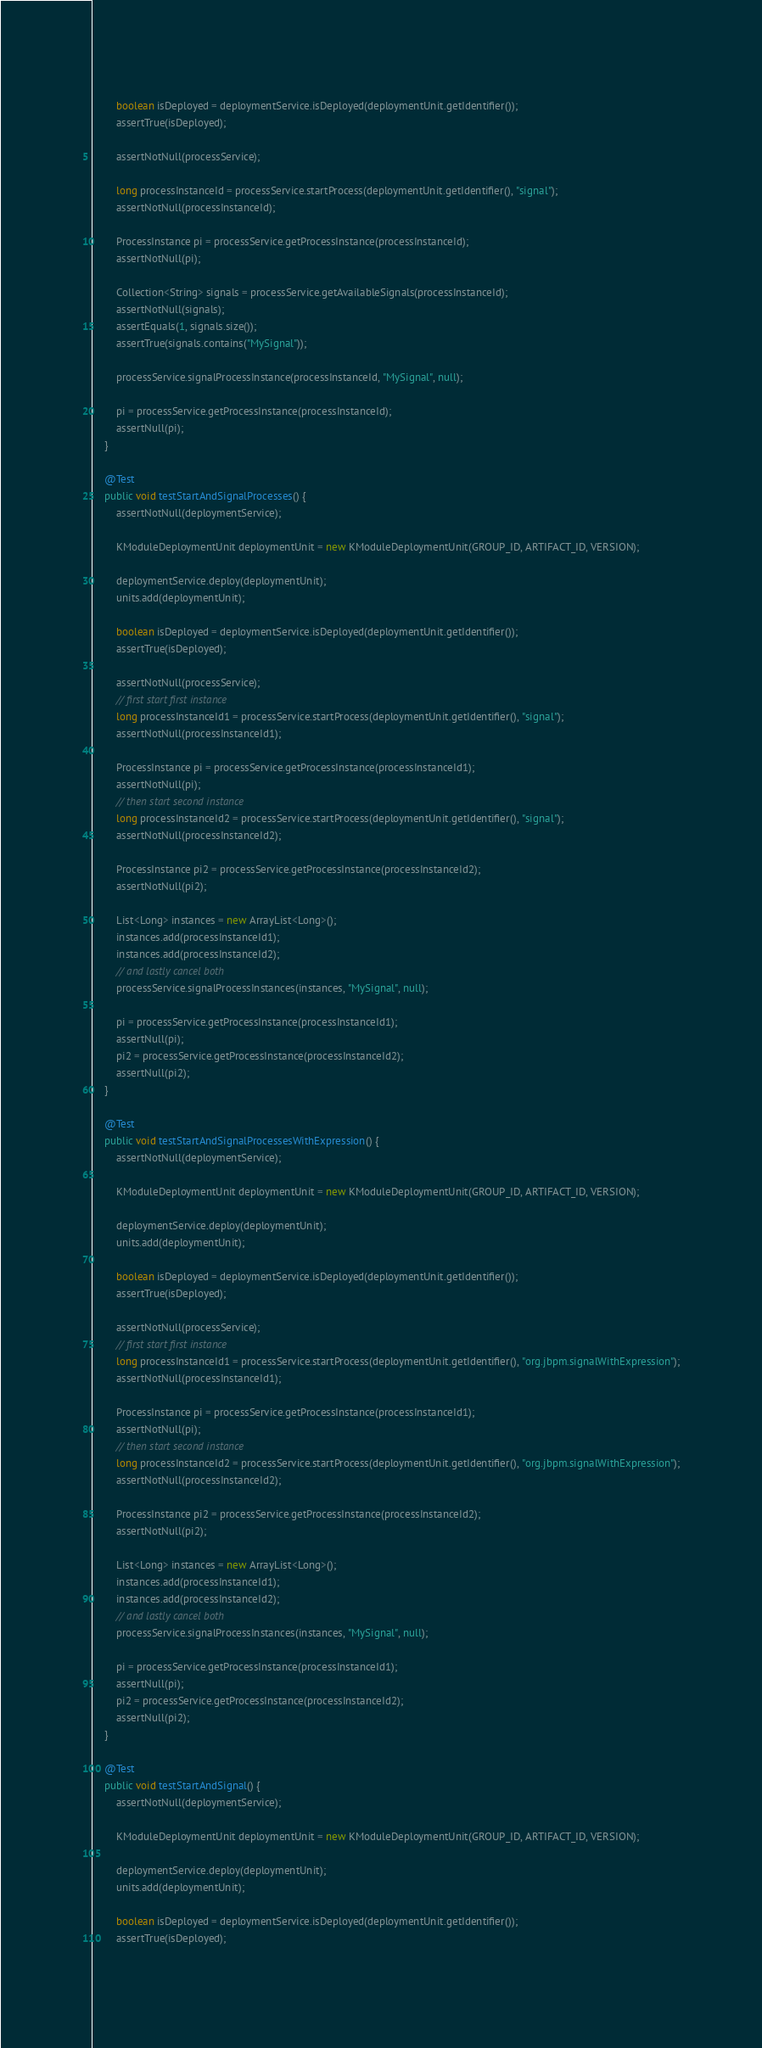<code> <loc_0><loc_0><loc_500><loc_500><_Java_>        
        boolean isDeployed = deploymentService.isDeployed(deploymentUnit.getIdentifier());
    	assertTrue(isDeployed);
    	
    	assertNotNull(processService);
    	
    	long processInstanceId = processService.startProcess(deploymentUnit.getIdentifier(), "signal");
    	assertNotNull(processInstanceId);
    	
    	ProcessInstance pi = processService.getProcessInstance(processInstanceId);    	
    	assertNotNull(pi);
    	
    	Collection<String> signals = processService.getAvailableSignals(processInstanceId);
    	assertNotNull(signals);
    	assertEquals(1, signals.size());
    	assertTrue(signals.contains("MySignal"));
    	
    	processService.signalProcessInstance(processInstanceId, "MySignal", null);
    	
    	pi = processService.getProcessInstance(processInstanceId);    	
    	assertNull(pi);
    }
    
    @Test
    public void testStartAndSignalProcesses() {
    	assertNotNull(deploymentService);
        
        KModuleDeploymentUnit deploymentUnit = new KModuleDeploymentUnit(GROUP_ID, ARTIFACT_ID, VERSION);
        
        deploymentService.deploy(deploymentUnit);
        units.add(deploymentUnit);
        
        boolean isDeployed = deploymentService.isDeployed(deploymentUnit.getIdentifier());
    	assertTrue(isDeployed);
    	
    	assertNotNull(processService);
    	// first start first instance
    	long processInstanceId1 = processService.startProcess(deploymentUnit.getIdentifier(), "signal");
    	assertNotNull(processInstanceId1);
    	
    	ProcessInstance pi = processService.getProcessInstance(processInstanceId1);    	
    	assertNotNull(pi);
    	// then start second instance
    	long processInstanceId2 = processService.startProcess(deploymentUnit.getIdentifier(), "signal");
    	assertNotNull(processInstanceId2);
    	
    	ProcessInstance pi2 = processService.getProcessInstance(processInstanceId2);    	
    	assertNotNull(pi2);
    	
    	List<Long> instances = new ArrayList<Long>();
    	instances.add(processInstanceId1);
    	instances.add(processInstanceId2);
    	// and lastly cancel both
    	processService.signalProcessInstances(instances, "MySignal", null);
    	
    	pi = processService.getProcessInstance(processInstanceId1);    	
    	assertNull(pi);
    	pi2 = processService.getProcessInstance(processInstanceId2);    	
    	assertNull(pi2);
    }

	@Test
	public void testStartAndSignalProcessesWithExpression() {
		assertNotNull(deploymentService);

		KModuleDeploymentUnit deploymentUnit = new KModuleDeploymentUnit(GROUP_ID, ARTIFACT_ID, VERSION);

		deploymentService.deploy(deploymentUnit);
		units.add(deploymentUnit);

		boolean isDeployed = deploymentService.isDeployed(deploymentUnit.getIdentifier());
		assertTrue(isDeployed);

		assertNotNull(processService);
		// first start first instance
		long processInstanceId1 = processService.startProcess(deploymentUnit.getIdentifier(), "org.jbpm.signalWithExpression");
		assertNotNull(processInstanceId1);

		ProcessInstance pi = processService.getProcessInstance(processInstanceId1);
		assertNotNull(pi);
		// then start second instance
		long processInstanceId2 = processService.startProcess(deploymentUnit.getIdentifier(), "org.jbpm.signalWithExpression");
		assertNotNull(processInstanceId2);

		ProcessInstance pi2 = processService.getProcessInstance(processInstanceId2);
		assertNotNull(pi2);

		List<Long> instances = new ArrayList<Long>();
		instances.add(processInstanceId1);
		instances.add(processInstanceId2);
		// and lastly cancel both
		processService.signalProcessInstances(instances, "MySignal", null);

		pi = processService.getProcessInstance(processInstanceId1);
		assertNull(pi);
		pi2 = processService.getProcessInstance(processInstanceId2);
		assertNull(pi2);
	}
    
    @Test
    public void testStartAndSignal() {
        assertNotNull(deploymentService);
        
        KModuleDeploymentUnit deploymentUnit = new KModuleDeploymentUnit(GROUP_ID, ARTIFACT_ID, VERSION);
        
        deploymentService.deploy(deploymentUnit);
        units.add(deploymentUnit);
        
        boolean isDeployed = deploymentService.isDeployed(deploymentUnit.getIdentifier());
        assertTrue(isDeployed);
        </code> 